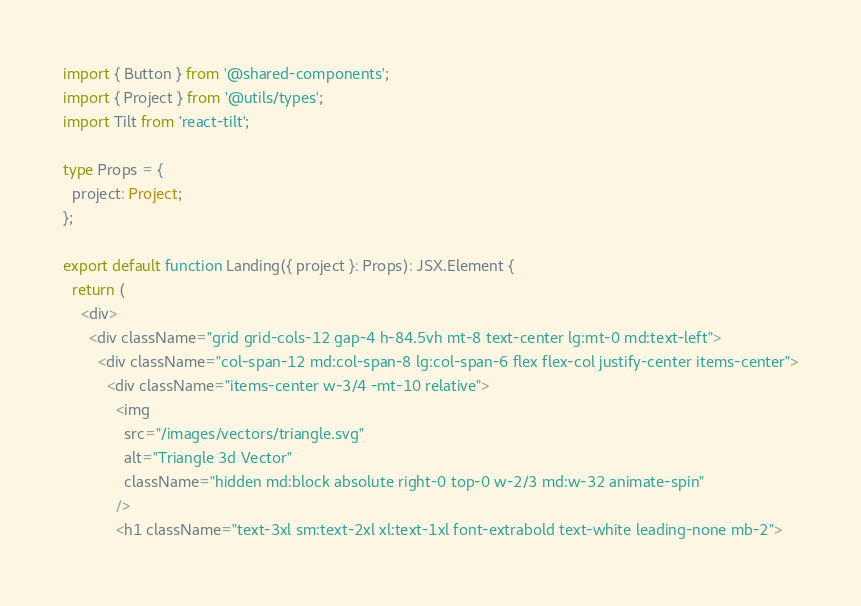<code> <loc_0><loc_0><loc_500><loc_500><_TypeScript_>import { Button } from '@shared-components';
import { Project } from '@utils/types';
import Tilt from 'react-tilt';

type Props = {
  project: Project;
};

export default function Landing({ project }: Props): JSX.Element {
  return (
    <div>
      <div className="grid grid-cols-12 gap-4 h-84.5vh mt-8 text-center lg:mt-0 md:text-left">
        <div className="col-span-12 md:col-span-8 lg:col-span-6 flex flex-col justify-center items-center">
          <div className="items-center w-3/4 -mt-10 relative">
            <img
              src="/images/vectors/triangle.svg"
              alt="Triangle 3d Vector"
              className="hidden md:block absolute right-0 top-0 w-2/3 md:w-32 animate-spin"
            />
            <h1 className="text-3xl sm:text-2xl xl:text-1xl font-extrabold text-white leading-none mb-2"></code> 